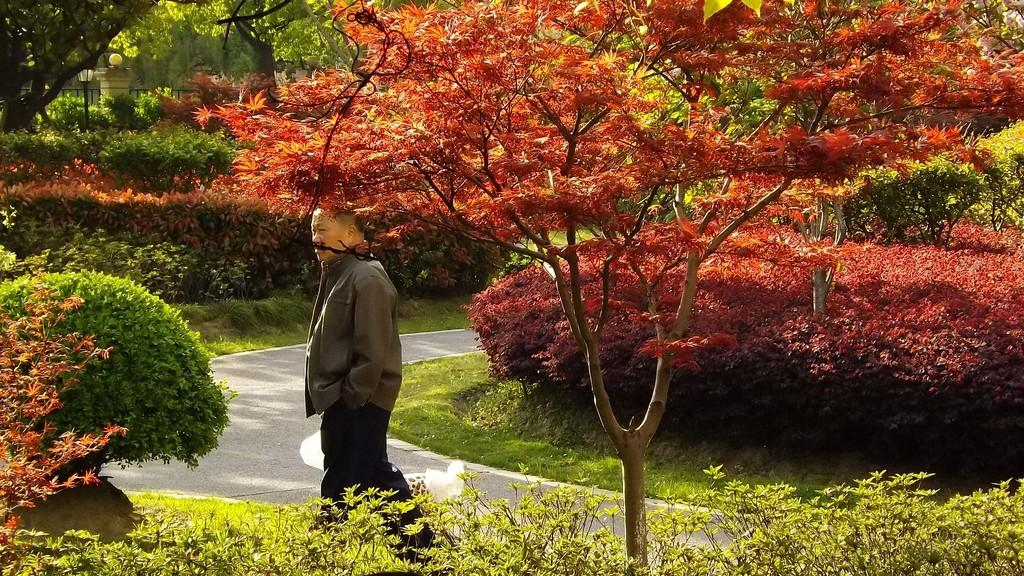What is the person in the image wearing? The person in the image is wearing a jacket. What type of natural environment is visible in the image? There are trees, plants, grass, and a fence in the image. What can be seen in the distance in the image? There is a light pole and a fence in the distance. What type of coal is being used to fuel the rings in the image? There is no coal or rings present in the image. 